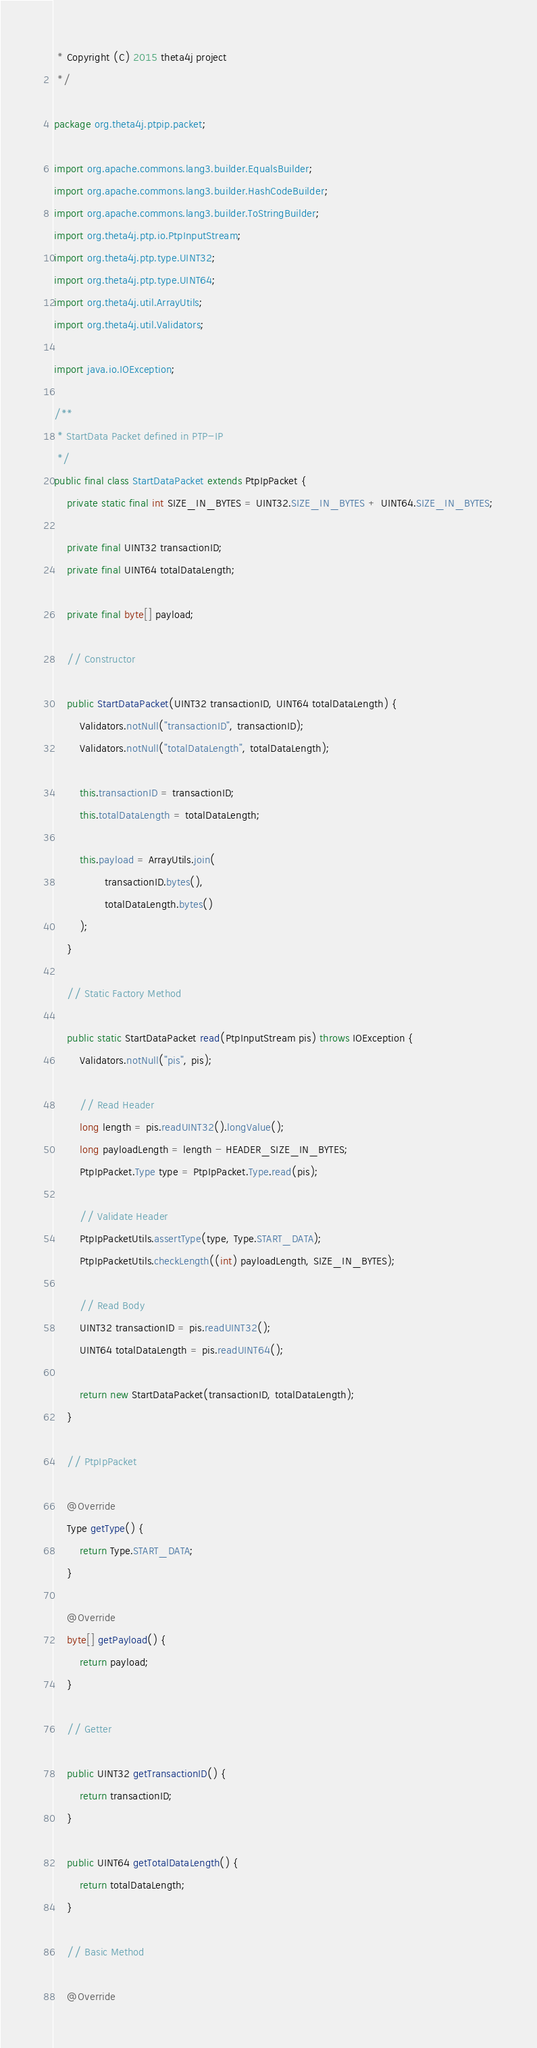<code> <loc_0><loc_0><loc_500><loc_500><_Java_> * Copyright (C) 2015 theta4j project
 */

package org.theta4j.ptpip.packet;

import org.apache.commons.lang3.builder.EqualsBuilder;
import org.apache.commons.lang3.builder.HashCodeBuilder;
import org.apache.commons.lang3.builder.ToStringBuilder;
import org.theta4j.ptp.io.PtpInputStream;
import org.theta4j.ptp.type.UINT32;
import org.theta4j.ptp.type.UINT64;
import org.theta4j.util.ArrayUtils;
import org.theta4j.util.Validators;

import java.io.IOException;

/**
 * StartData Packet defined in PTP-IP
 */
public final class StartDataPacket extends PtpIpPacket {
    private static final int SIZE_IN_BYTES = UINT32.SIZE_IN_BYTES + UINT64.SIZE_IN_BYTES;

    private final UINT32 transactionID;
    private final UINT64 totalDataLength;

    private final byte[] payload;

    // Constructor

    public StartDataPacket(UINT32 transactionID, UINT64 totalDataLength) {
        Validators.notNull("transactionID", transactionID);
        Validators.notNull("totalDataLength", totalDataLength);

        this.transactionID = transactionID;
        this.totalDataLength = totalDataLength;

        this.payload = ArrayUtils.join(
                transactionID.bytes(),
                totalDataLength.bytes()
        );
    }

    // Static Factory Method

    public static StartDataPacket read(PtpInputStream pis) throws IOException {
        Validators.notNull("pis", pis);

        // Read Header
        long length = pis.readUINT32().longValue();
        long payloadLength = length - HEADER_SIZE_IN_BYTES;
        PtpIpPacket.Type type = PtpIpPacket.Type.read(pis);

        // Validate Header
        PtpIpPacketUtils.assertType(type, Type.START_DATA);
        PtpIpPacketUtils.checkLength((int) payloadLength, SIZE_IN_BYTES);

        // Read Body
        UINT32 transactionID = pis.readUINT32();
        UINT64 totalDataLength = pis.readUINT64();

        return new StartDataPacket(transactionID, totalDataLength);
    }

    // PtpIpPacket

    @Override
    Type getType() {
        return Type.START_DATA;
    }

    @Override
    byte[] getPayload() {
        return payload;
    }

    // Getter

    public UINT32 getTransactionID() {
        return transactionID;
    }

    public UINT64 getTotalDataLength() {
        return totalDataLength;
    }

    // Basic Method

    @Override</code> 